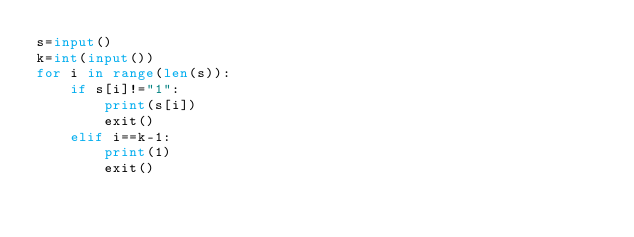<code> <loc_0><loc_0><loc_500><loc_500><_Python_>s=input()
k=int(input())
for i in range(len(s)):
	if s[i]!="1":
		print(s[i])
		exit()
	elif i==k-1:
		print(1)
		exit()</code> 